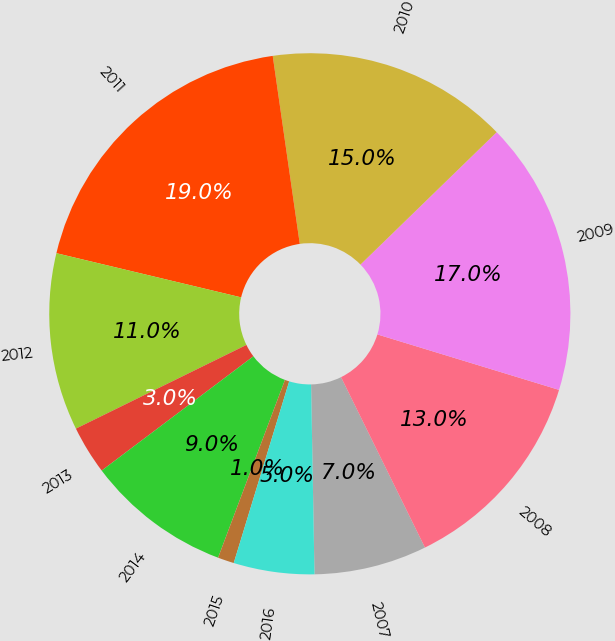Convert chart to OTSL. <chart><loc_0><loc_0><loc_500><loc_500><pie_chart><fcel>2007<fcel>2008<fcel>2009<fcel>2010<fcel>2011<fcel>2012<fcel>2013<fcel>2014<fcel>2015<fcel>2016<nl><fcel>7.0%<fcel>13.0%<fcel>16.99%<fcel>15.0%<fcel>18.99%<fcel>11.0%<fcel>3.01%<fcel>9.0%<fcel>1.01%<fcel>5.0%<nl></chart> 